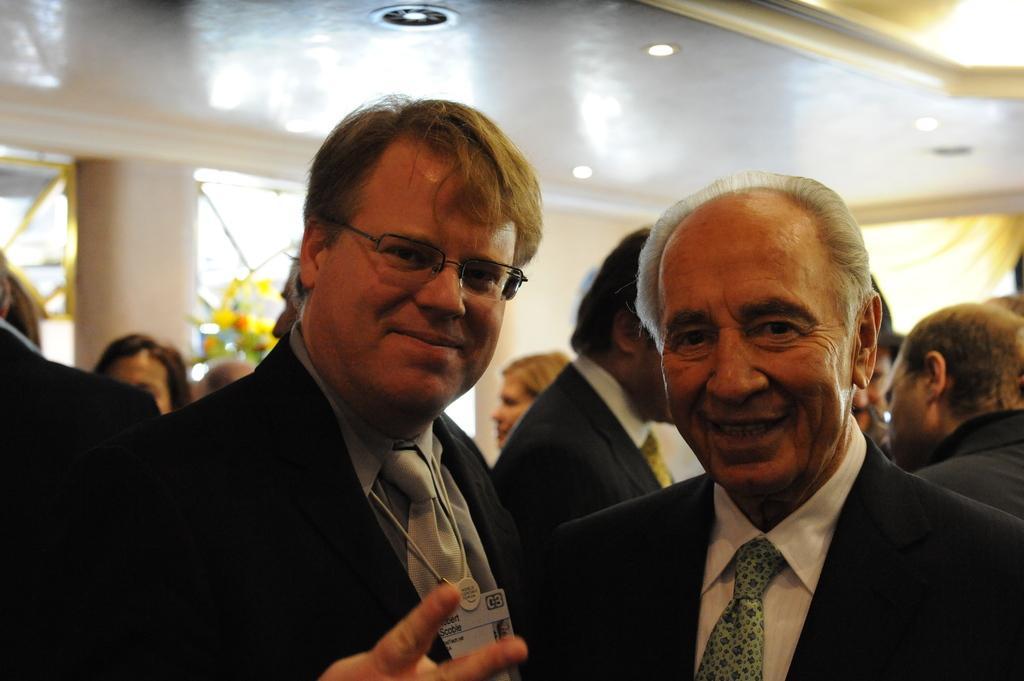Could you give a brief overview of what you see in this image? In this image there are two persons in the front side. Behind them, many people are there. On the left backside there is a pillar. 